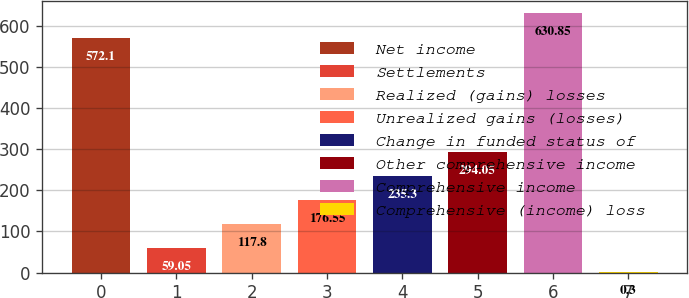Convert chart to OTSL. <chart><loc_0><loc_0><loc_500><loc_500><bar_chart><fcel>Net income<fcel>Settlements<fcel>Realized (gains) losses<fcel>Unrealized gains (losses)<fcel>Change in funded status of<fcel>Other comprehensive income<fcel>Comprehensive income<fcel>Comprehensive (income) loss<nl><fcel>572.1<fcel>59.05<fcel>117.8<fcel>176.55<fcel>235.3<fcel>294.05<fcel>630.85<fcel>0.3<nl></chart> 